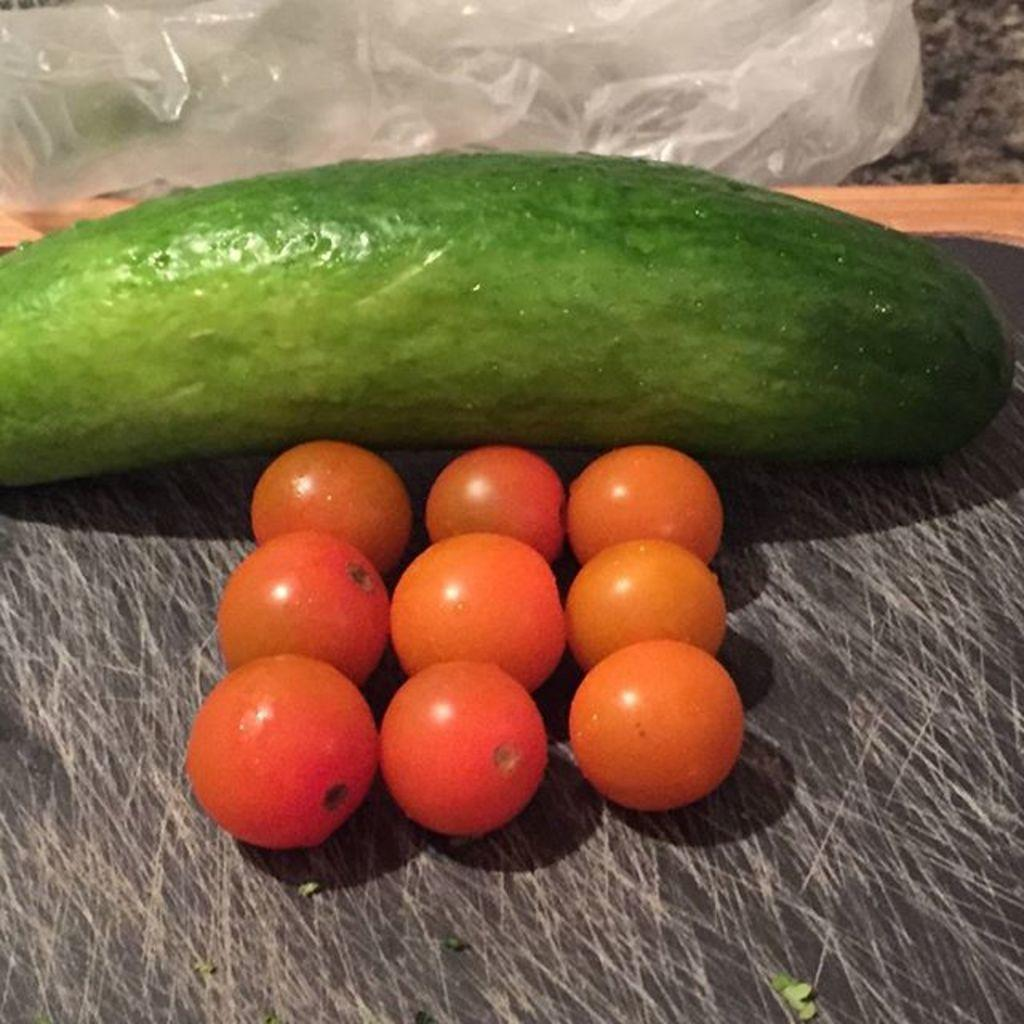What type of food can be seen in the center of the image? There are vegetables in the center of the image. What is the purpose of the cover in the image? The purpose of the cover is not specified, but it may be used to protect or preserve the vegetables. How does the pencil feel about the vegetables in the image? There is no pencil present in the image, so it is not possible to determine how it might feel about the vegetables. 